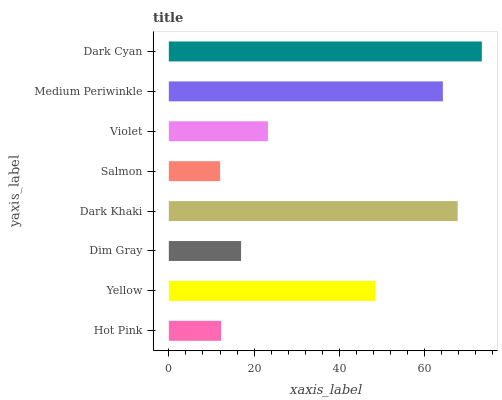Is Salmon the minimum?
Answer yes or no. Yes. Is Dark Cyan the maximum?
Answer yes or no. Yes. Is Yellow the minimum?
Answer yes or no. No. Is Yellow the maximum?
Answer yes or no. No. Is Yellow greater than Hot Pink?
Answer yes or no. Yes. Is Hot Pink less than Yellow?
Answer yes or no. Yes. Is Hot Pink greater than Yellow?
Answer yes or no. No. Is Yellow less than Hot Pink?
Answer yes or no. No. Is Yellow the high median?
Answer yes or no. Yes. Is Violet the low median?
Answer yes or no. Yes. Is Dim Gray the high median?
Answer yes or no. No. Is Dim Gray the low median?
Answer yes or no. No. 